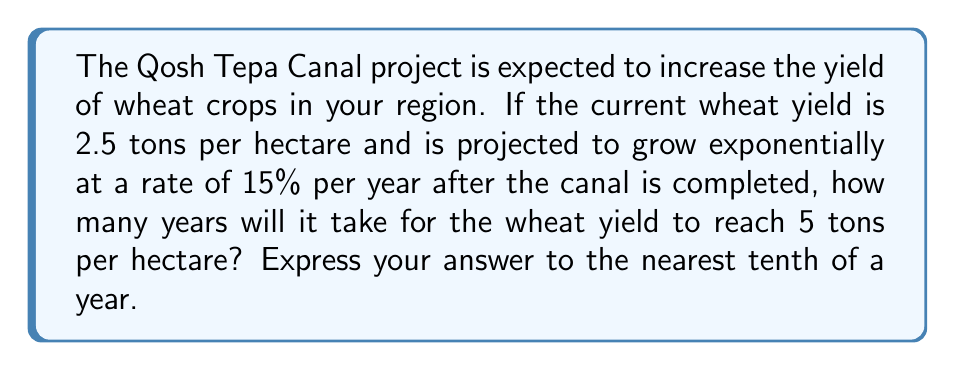Can you solve this math problem? To solve this problem, we'll use an exponential function and apply the concept of derivatives to find the growth rate. Let's approach this step-by-step:

1) Let's define our exponential function:
   $Y(t) = 2.5e^{0.15t}$
   Where $Y$ is the yield in tons per hectare, and $t$ is the time in years.

2) We want to find when $Y(t) = 5$. So, we set up the equation:
   $5 = 2.5e^{0.15t}$

3) Divide both sides by 2.5:
   $2 = e^{0.15t}$

4) Take the natural logarithm of both sides:
   $\ln(2) = 0.15t$

5) Solve for $t$:
   $t = \frac{\ln(2)}{0.15}$

6) Calculate the value:
   $t = \frac{0.693147...}{0.15} \approx 4.6209...$ years

7) Rounding to the nearest tenth:
   $t \approx 4.6$ years

To verify that this is indeed the point where the yield reaches 5 tons per hectare, we can calculate the derivative of our function to confirm the growth rate:

$\frac{dY}{dt} = 2.5 \cdot 0.15 \cdot e^{0.15t}$

At $t=0$, this gives us:
$\frac{dY}{dt}|_{t=0} = 2.5 \cdot 0.15 = 0.375$

This means the initial growth rate is 0.375 tons per hectare per year, which is indeed 15% of the initial yield of 2.5 tons per hectare.
Answer: 4.6 years 